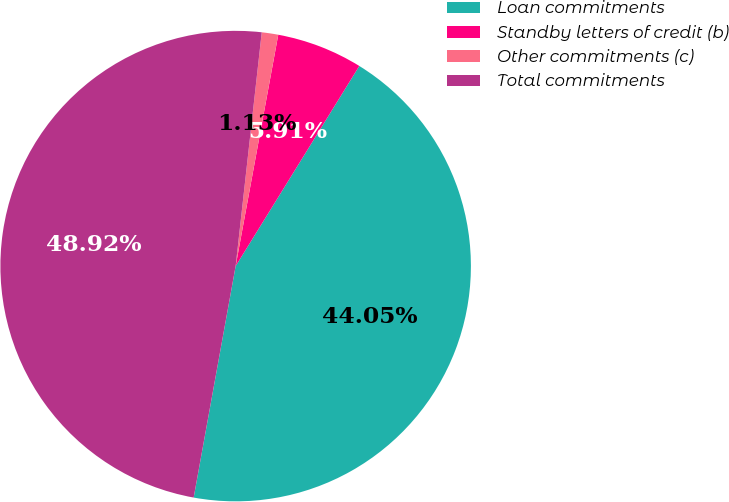Convert chart to OTSL. <chart><loc_0><loc_0><loc_500><loc_500><pie_chart><fcel>Loan commitments<fcel>Standby letters of credit (b)<fcel>Other commitments (c)<fcel>Total commitments<nl><fcel>44.05%<fcel>5.91%<fcel>1.13%<fcel>48.92%<nl></chart> 